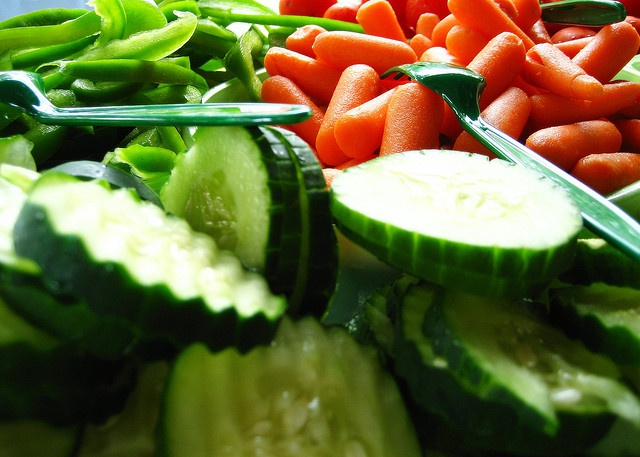Describe the objects in this image and their specific colors. I can see carrot in lightblue, brown, red, and ivory tones, fork in lightblue, white, black, turquoise, and aquamarine tones, carrot in lightblue, maroon, red, and tan tones, carrot in lightblue, brown, red, and white tones, and carrot in lightblue, maroon, orange, and red tones in this image. 